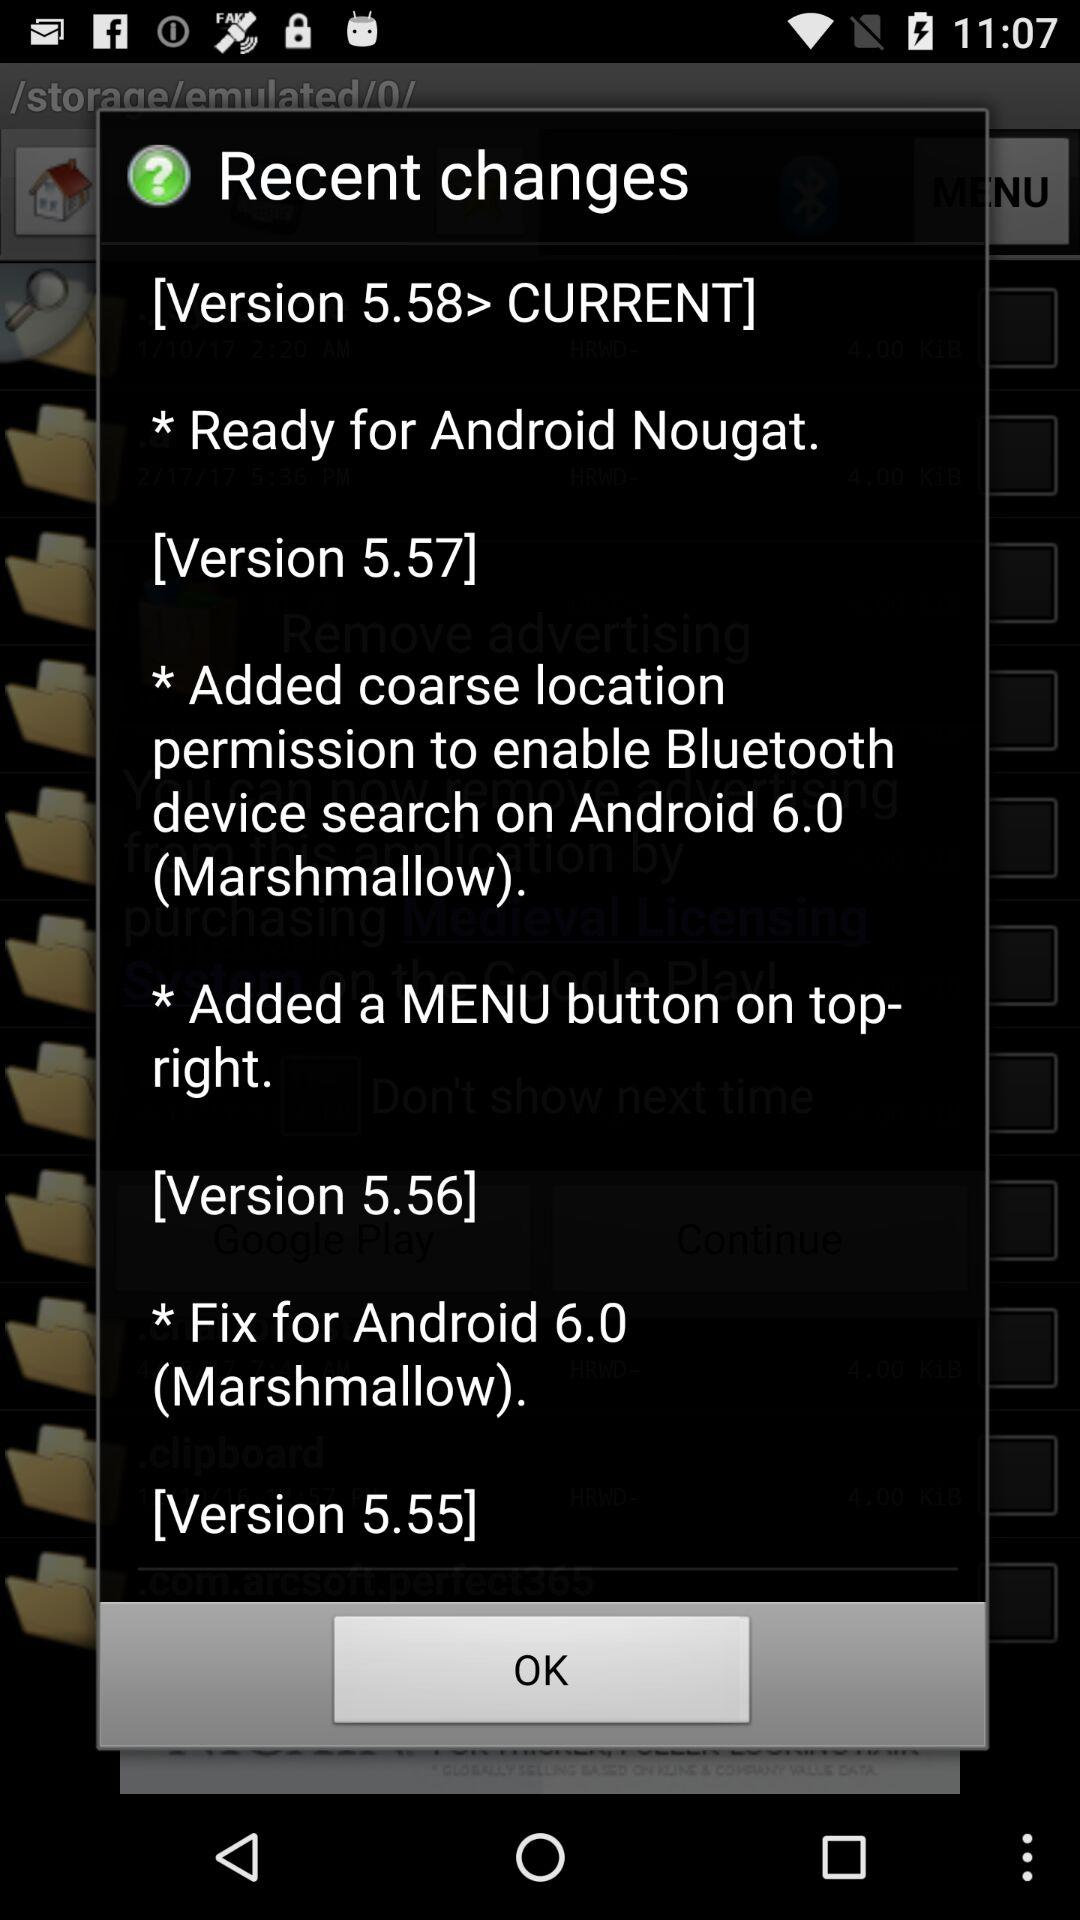What is the version number of Marshmallow? The version number of Marshmallow is 6.0. 